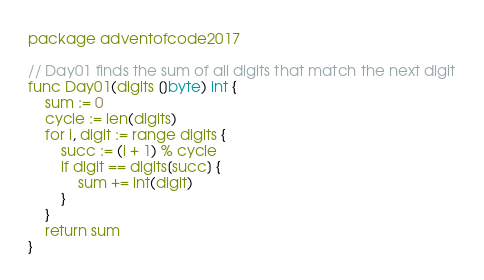<code> <loc_0><loc_0><loc_500><loc_500><_Go_>package adventofcode2017

// Day01 finds the sum of all digits that match the next digit
func Day01(digits []byte) int {
	sum := 0
	cycle := len(digits)
	for i, digit := range digits {
		succ := (i + 1) % cycle
		if digit == digits[succ] {
			sum += int(digit)
		}
	}
	return sum
}
</code> 